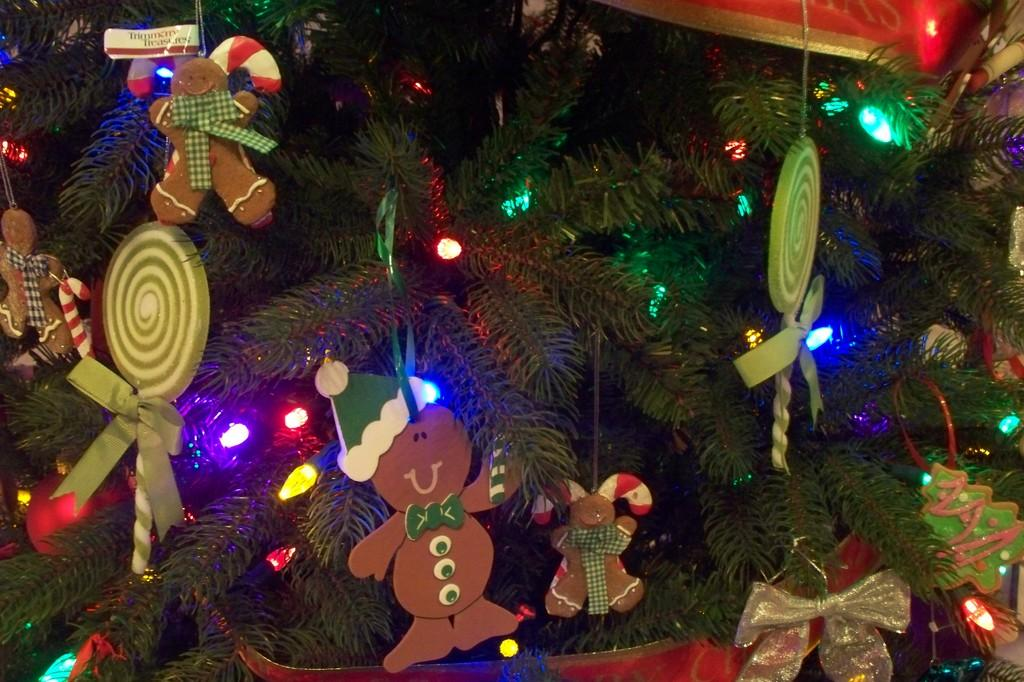What type of objects can be seen in the image? There are toys and lights visible in the image. What is the plant in the image placed in? The plant is in a pot. What is attached to the plant in the image? There are objects tied to the plant in the image. Can you see a basin in the image? There is no basin present in the image. Is the plant located on a sidewalk in the image? There is no sidewalk present in the image. 